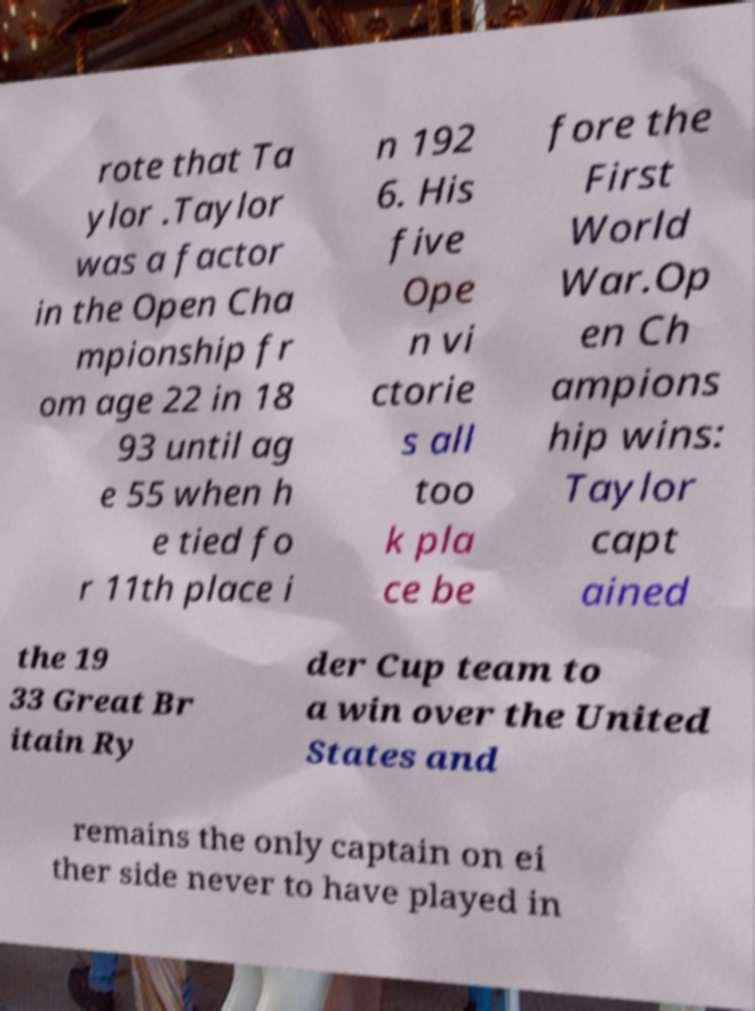Could you extract and type out the text from this image? rote that Ta ylor .Taylor was a factor in the Open Cha mpionship fr om age 22 in 18 93 until ag e 55 when h e tied fo r 11th place i n 192 6. His five Ope n vi ctorie s all too k pla ce be fore the First World War.Op en Ch ampions hip wins: Taylor capt ained the 19 33 Great Br itain Ry der Cup team to a win over the United States and remains the only captain on ei ther side never to have played in 